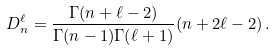Convert formula to latex. <formula><loc_0><loc_0><loc_500><loc_500>D _ { n } ^ { \ell } = \frac { \Gamma ( n + \ell - 2 ) } { \Gamma ( n - 1 ) \Gamma ( \ell + 1 ) } ( n + 2 \ell - 2 ) \, .</formula> 